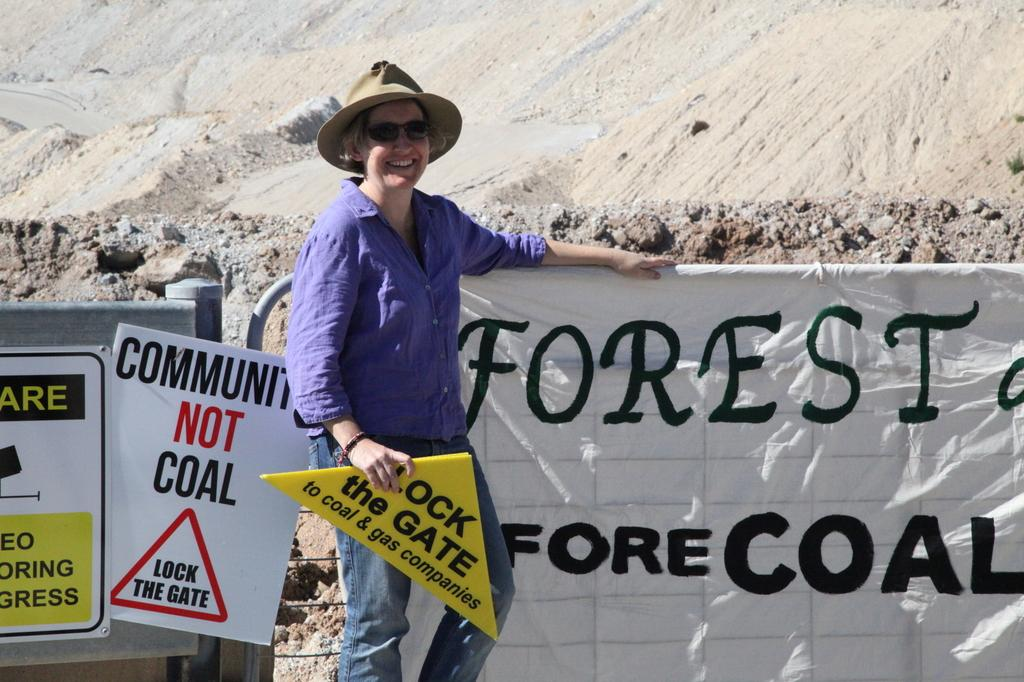What is the person in the image doing? The person is standing and smiling in the image. What accessories is the person wearing? The person is wearing a hat and goggles. What is the person holding in the image? The person is holding a yellow board. What can be seen in the background of the image? There are mountains visible in the background of the image. What additional element is present in the image? There is a banner in the image. How many lumber pieces can be seen on the person's head in the image? There are no lumber pieces present on the person's head in the image. What type of lizards can be seen crawling on the yellow board in the image? There are no lizards present in the image, and the yellow board is not being crawled on by any creatures. 